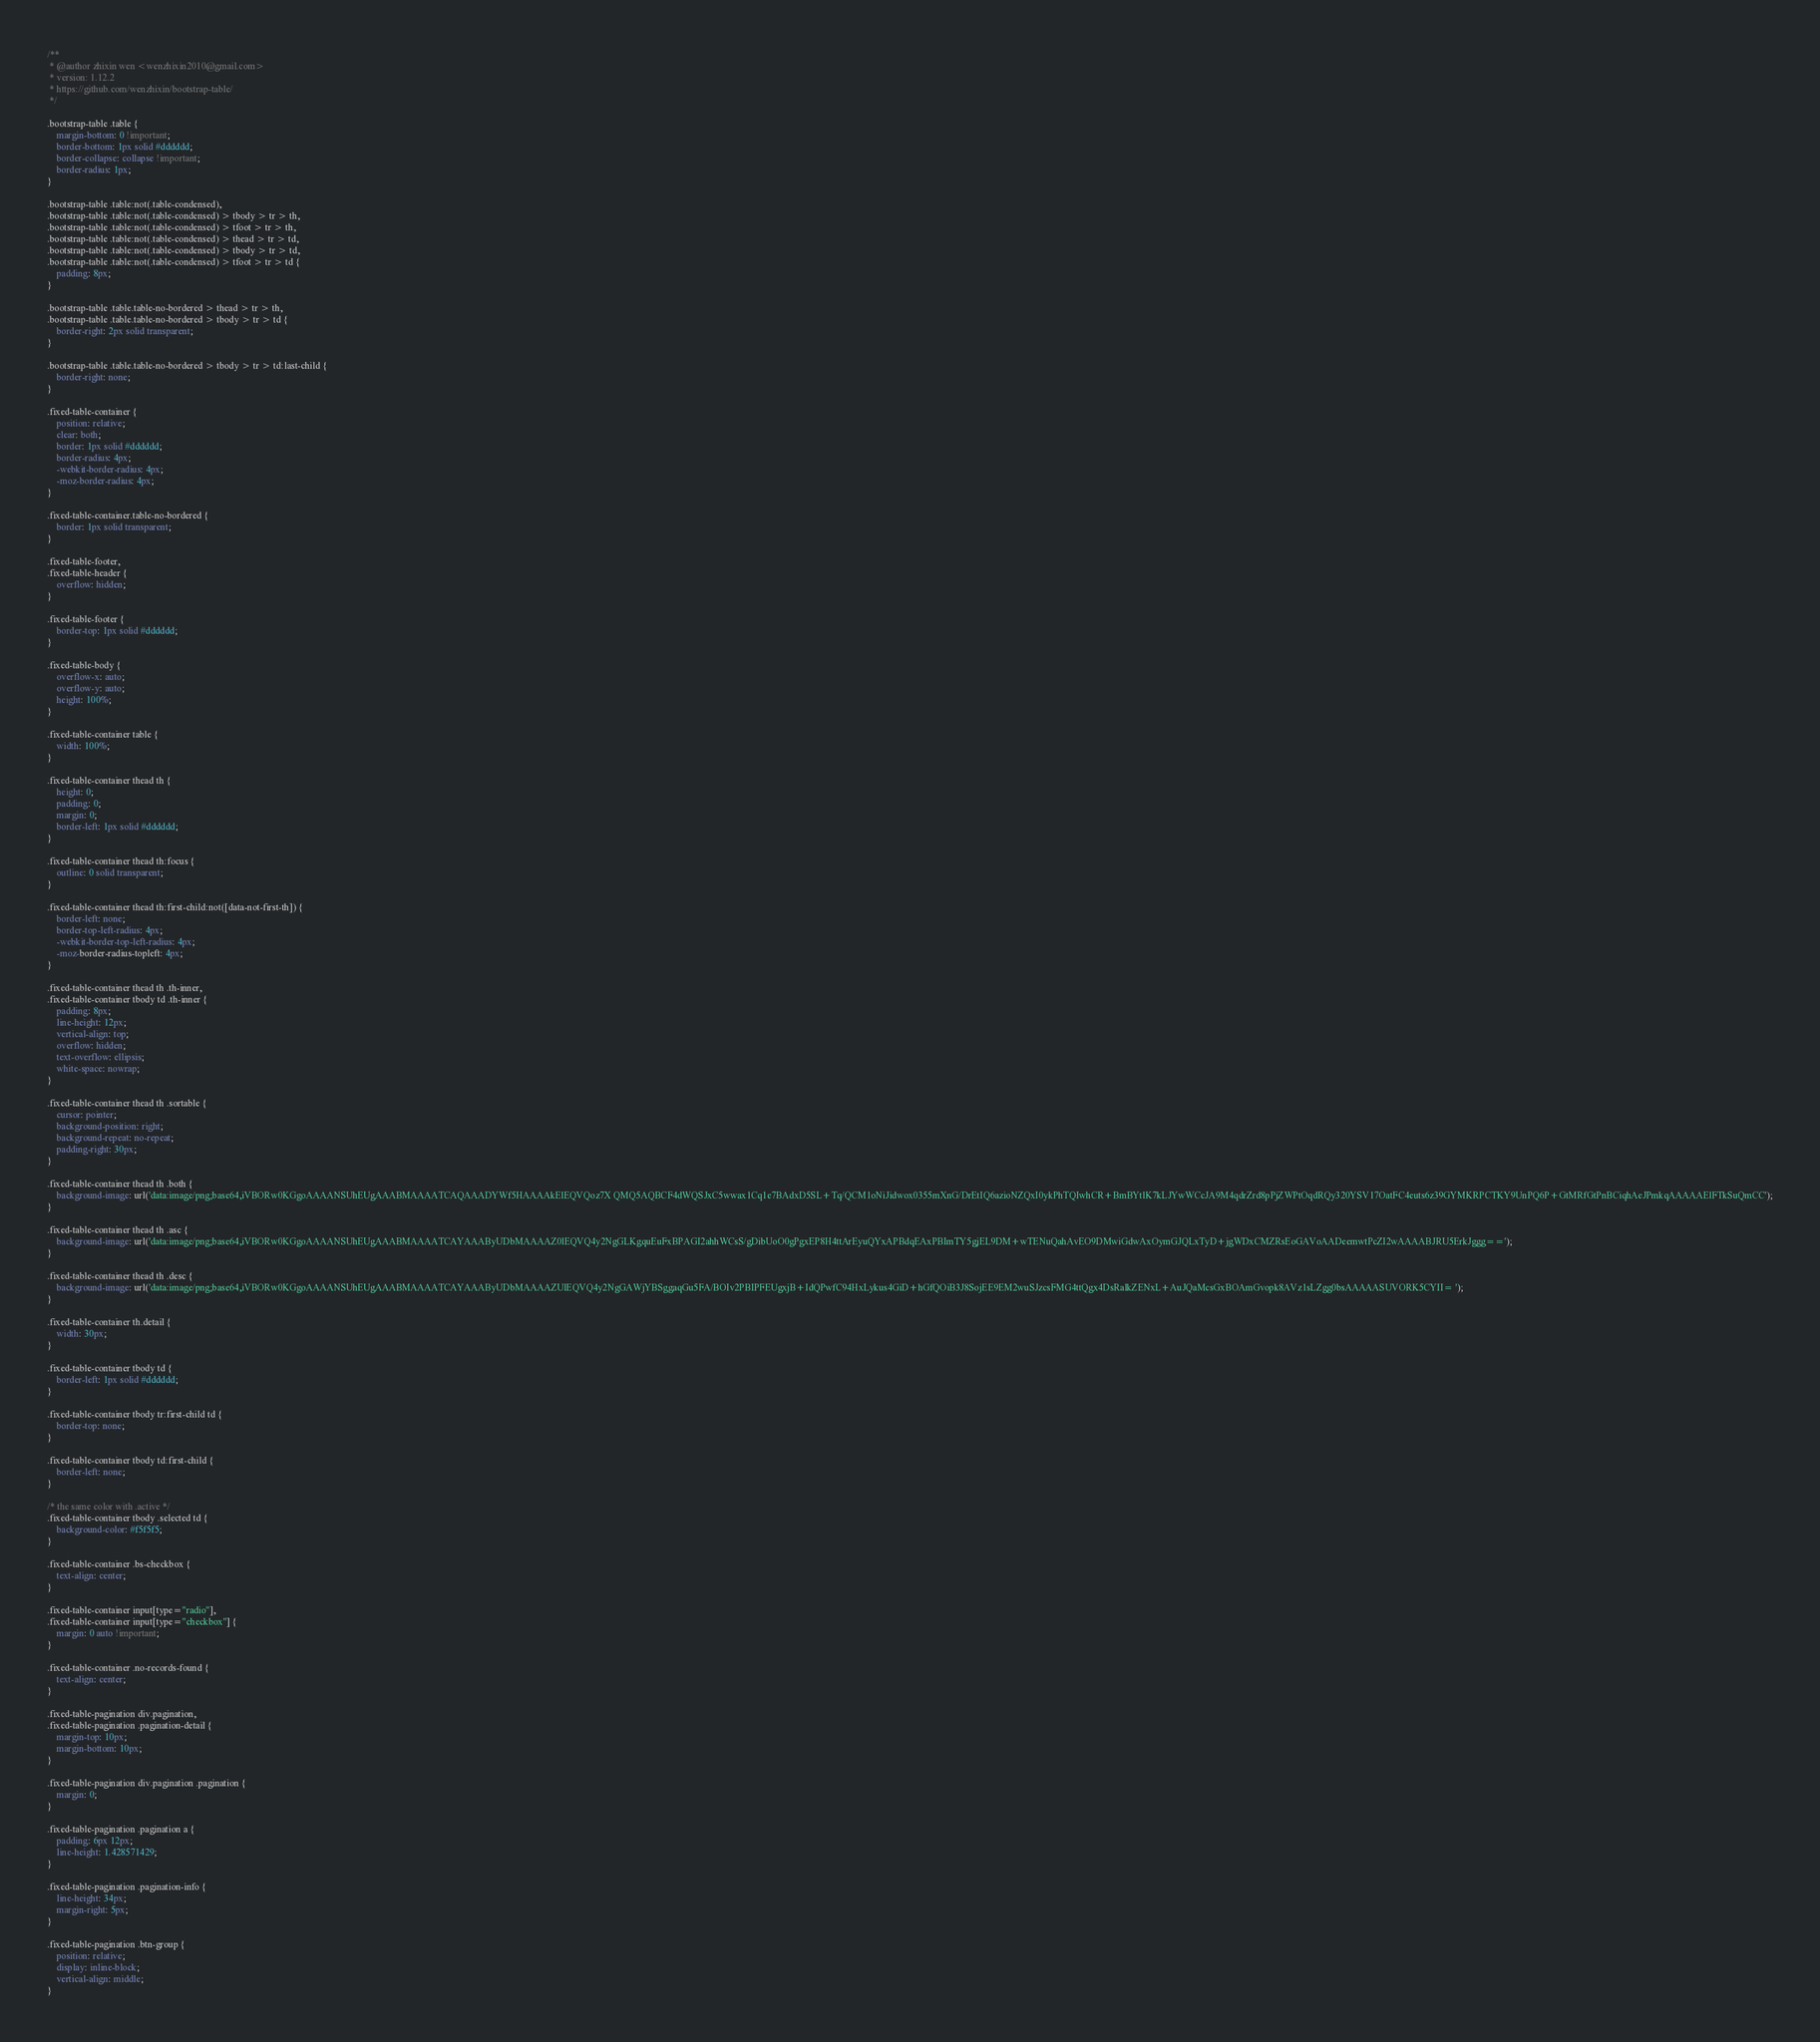<code> <loc_0><loc_0><loc_500><loc_500><_CSS_>/**
 * @author zhixin wen <wenzhixin2010@gmail.com>
 * version: 1.12.2
 * https://github.com/wenzhixin/bootstrap-table/
 */

.bootstrap-table .table {
    margin-bottom: 0 !important;
    border-bottom: 1px solid #dddddd;
    border-collapse: collapse !important;
    border-radius: 1px;
}

.bootstrap-table .table:not(.table-condensed),
.bootstrap-table .table:not(.table-condensed) > tbody > tr > th,
.bootstrap-table .table:not(.table-condensed) > tfoot > tr > th,
.bootstrap-table .table:not(.table-condensed) > thead > tr > td,
.bootstrap-table .table:not(.table-condensed) > tbody > tr > td,
.bootstrap-table .table:not(.table-condensed) > tfoot > tr > td {
    padding: 8px;
}

.bootstrap-table .table.table-no-bordered > thead > tr > th,
.bootstrap-table .table.table-no-bordered > tbody > tr > td {
    border-right: 2px solid transparent;
}

.bootstrap-table .table.table-no-bordered > tbody > tr > td:last-child {
    border-right: none;
}

.fixed-table-container {
    position: relative;
    clear: both;
    border: 1px solid #dddddd;
    border-radius: 4px;
    -webkit-border-radius: 4px;
    -moz-border-radius: 4px;
}

.fixed-table-container.table-no-bordered {
    border: 1px solid transparent;
}

.fixed-table-footer,
.fixed-table-header {
    overflow: hidden;
}

.fixed-table-footer {
    border-top: 1px solid #dddddd;
}

.fixed-table-body {
    overflow-x: auto;
    overflow-y: auto;
    height: 100%;
}

.fixed-table-container table {
    width: 100%;
}

.fixed-table-container thead th {
    height: 0;
    padding: 0;
    margin: 0;
    border-left: 1px solid #dddddd;
}

.fixed-table-container thead th:focus {
    outline: 0 solid transparent;
}

.fixed-table-container thead th:first-child:not([data-not-first-th]) {
    border-left: none;
    border-top-left-radius: 4px;
    -webkit-border-top-left-radius: 4px;
    -moz-border-radius-topleft: 4px;
}

.fixed-table-container thead th .th-inner,
.fixed-table-container tbody td .th-inner {
    padding: 8px;
    line-height: 12px;
    vertical-align: top;
    overflow: hidden;
    text-overflow: ellipsis;
    white-space: nowrap;
}

.fixed-table-container thead th .sortable {
    cursor: pointer;
    background-position: right;
    background-repeat: no-repeat;
    padding-right: 30px;
}

.fixed-table-container thead th .both {
    background-image: url('data:image/png;base64,iVBORw0KGgoAAAANSUhEUgAAABMAAAATCAQAAADYWf5HAAAAkElEQVQoz7X QMQ5AQBCF4dWQSJxC5wwax1Cq1e7BAdxD5SL+Tq/QCM1oNiJidwox0355mXnG/DrEtIQ6azioNZQxI0ykPhTQIwhCR+BmBYtlK7kLJYwWCcJA9M4qdrZrd8pPjZWPtOqdRQy320YSV17OatFC4euts6z39GYMKRPCTKY9UnPQ6P+GtMRfGtPnBCiqhAeJPmkqAAAAAElFTkSuQmCC');
}

.fixed-table-container thead th .asc {
    background-image: url('data:image/png;base64,iVBORw0KGgoAAAANSUhEUgAAABMAAAATCAYAAAByUDbMAAAAZ0lEQVQ4y2NgGLKgquEuFxBPAGI2ahhWCsS/gDibUoO0gPgxEP8H4ttArEyuQYxAPBdqEAxPBImTY5gjEL9DM+wTENuQahAvEO9DMwiGdwAxOymGJQLxTyD+jgWDxCMZRsEoGAVoAADeemwtPcZI2wAAAABJRU5ErkJggg==');
}

.fixed-table-container thead th .desc {
    background-image: url('data:image/png;base64,iVBORw0KGgoAAAANSUhEUgAAABMAAAATCAYAAAByUDbMAAAAZUlEQVQ4y2NgGAWjYBSggaqGu5FA/BOIv2PBIPFEUgxjB+IdQPwfC94HxLykus4GiD+hGfQOiB3J8SojEE9EM2wuSJzcsFMG4ttQgx4DsRalkZENxL+AuJQaMcsGxBOAmGvopk8AVz1sLZgg0bsAAAAASUVORK5CYII= ');
}

.fixed-table-container th.detail {
    width: 30px;
}

.fixed-table-container tbody td {
    border-left: 1px solid #dddddd;
}

.fixed-table-container tbody tr:first-child td {
    border-top: none;
}

.fixed-table-container tbody td:first-child {
    border-left: none;
}

/* the same color with .active */
.fixed-table-container tbody .selected td {
    background-color: #f5f5f5;
}

.fixed-table-container .bs-checkbox {
    text-align: center;
}

.fixed-table-container input[type="radio"],
.fixed-table-container input[type="checkbox"] {
    margin: 0 auto !important;
}

.fixed-table-container .no-records-found {
    text-align: center;
}

.fixed-table-pagination div.pagination,
.fixed-table-pagination .pagination-detail {
    margin-top: 10px;
    margin-bottom: 10px;
}

.fixed-table-pagination div.pagination .pagination {
    margin: 0;
}

.fixed-table-pagination .pagination a {
    padding: 6px 12px;
    line-height: 1.428571429;
}

.fixed-table-pagination .pagination-info {
    line-height: 34px;
    margin-right: 5px;
}

.fixed-table-pagination .btn-group {
    position: relative;
    display: inline-block;
    vertical-align: middle;
}
</code> 